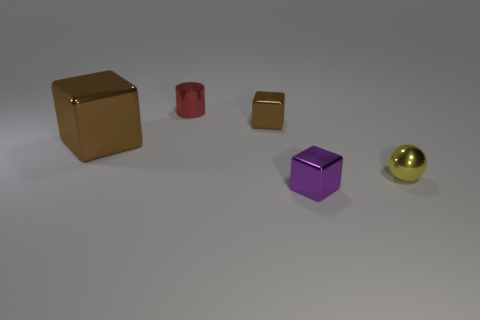There is another thing that is the same color as the large metal object; what shape is it?
Your response must be concise. Cube. Does the small brown thing have the same shape as the tiny purple metal thing on the right side of the small red cylinder?
Provide a short and direct response. Yes. There is a red thing that is made of the same material as the big block; what is its size?
Keep it short and to the point. Small. Is there anything else of the same color as the big cube?
Offer a very short reply. Yes. There is a cube that is in front of the tiny thing that is right of the object in front of the yellow metallic sphere; what is its material?
Make the answer very short. Metal. What number of shiny objects are either cubes or small cylinders?
Offer a very short reply. 4. Is the tiny sphere the same color as the cylinder?
Your answer should be compact. No. Is there any other thing that is made of the same material as the red thing?
Provide a succinct answer. Yes. How many objects are small spheres or objects in front of the yellow thing?
Provide a succinct answer. 2. There is a object in front of the shiny ball; does it have the same size as the red metal object?
Offer a terse response. Yes. 